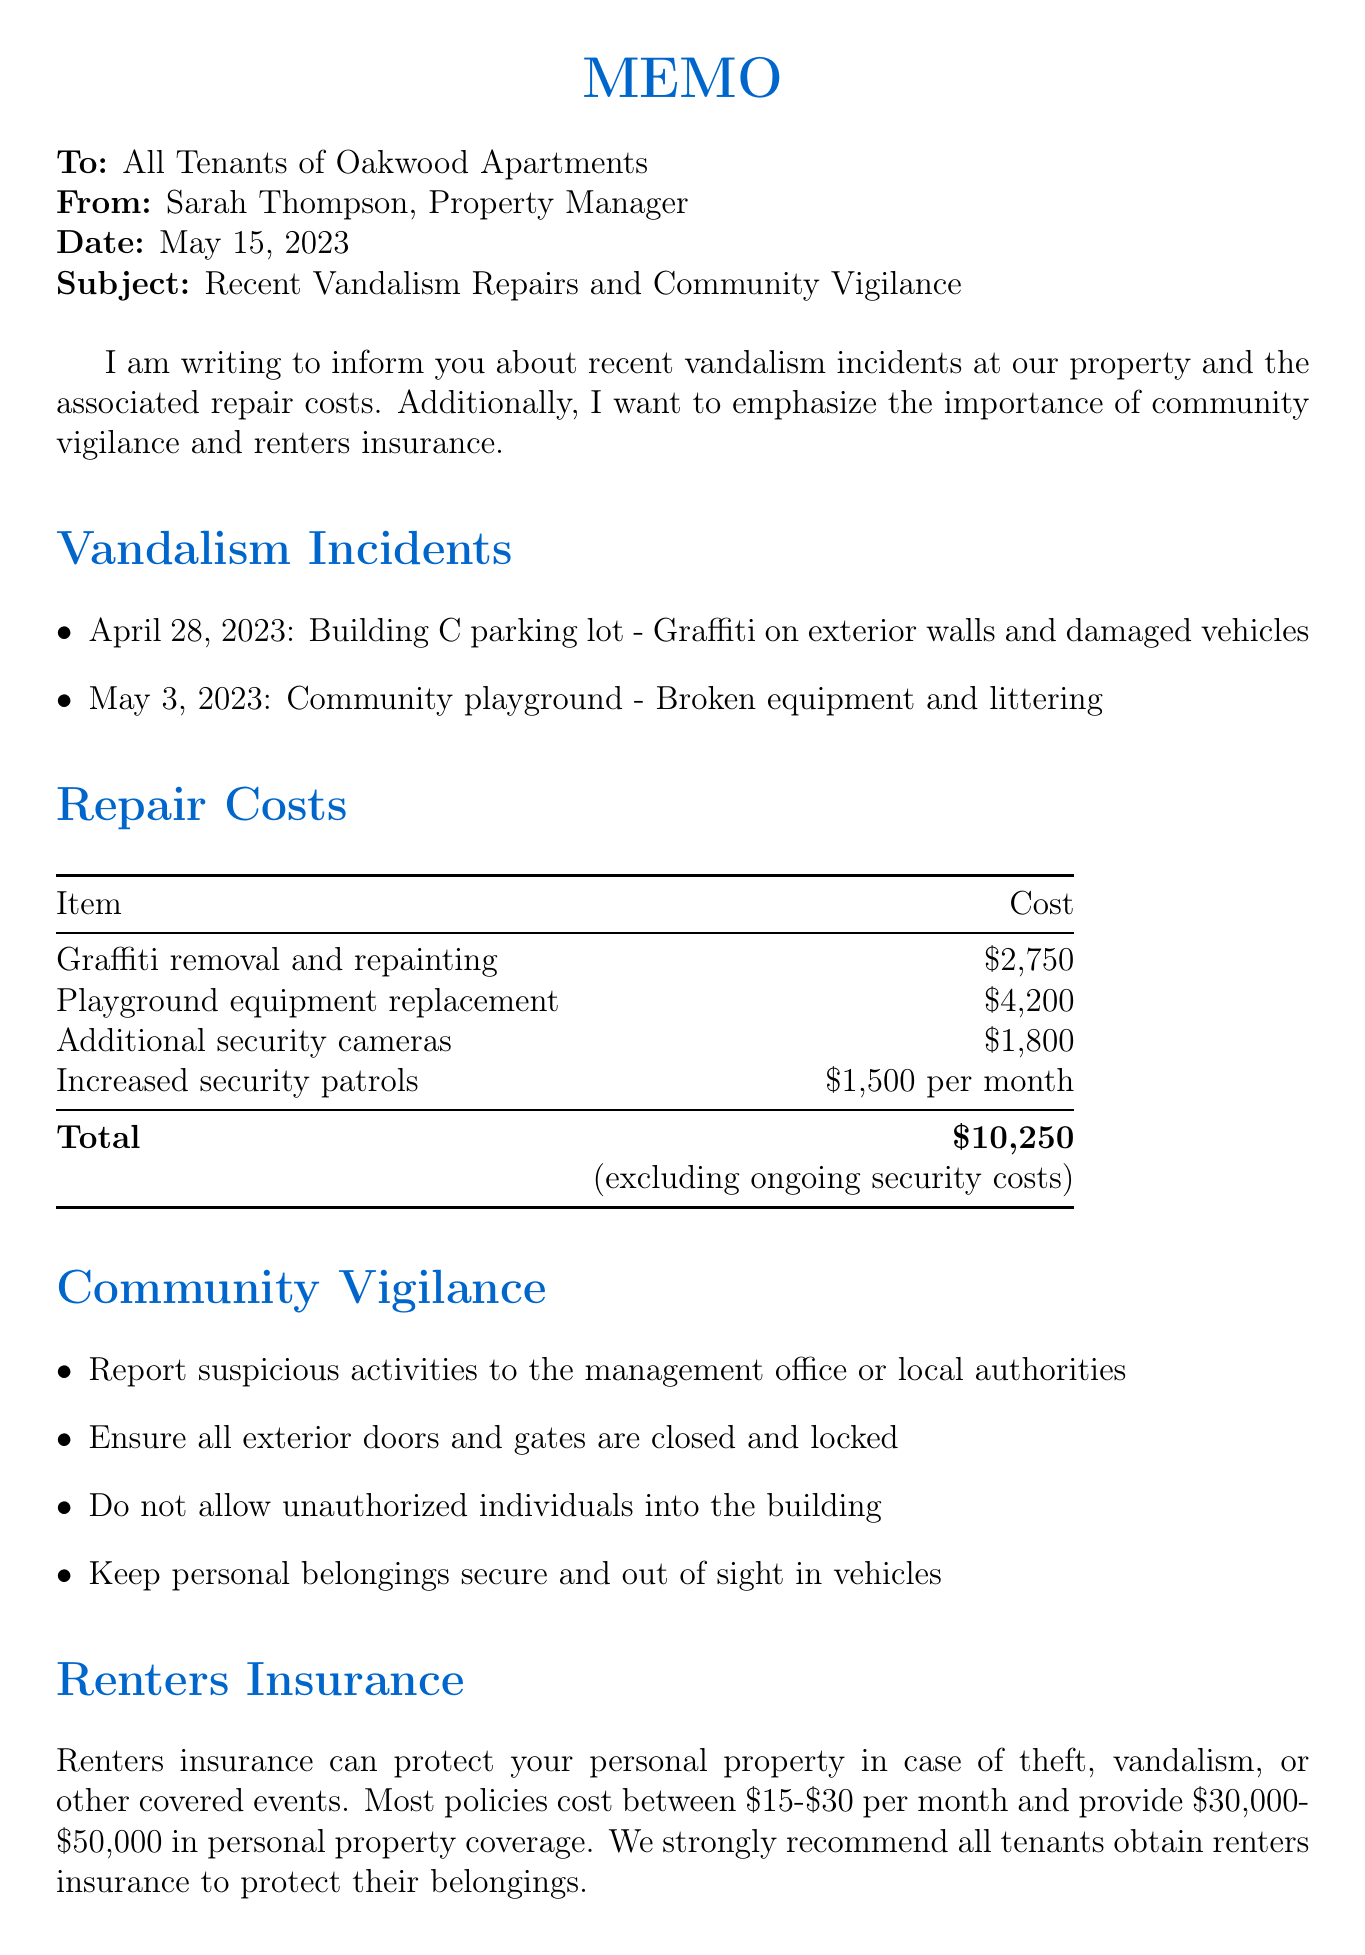what date was the memo issued? The memo was issued on May 15, 2023, as indicated in the document.
Answer: May 15, 2023 how much did the graffiti removal cost? The cost for graffiti removal and repainting is listed as $2,750 in the repair costs section.
Answer: $2,750 what was damaged in the Building C parking lot? The document mentions graffiti on exterior walls and damaged vehicles in the Building C parking lot.
Answer: Graffiti on exterior walls and damaged vehicles how much is the estimated total repair cost? The total repair cost is clearly stated as $10,250 in the repair costs table.
Answer: $10,250 what measures are suggested for community vigilance? The memo lists several measures, including reporting suspicious activities and ensuring doors are locked, highlighting the importance of community vigilance.
Answer: Report suspicious activities to the management office or local authorities what coverage do most renters insurance policies provide? The document states that most policies provide $30,000-$50,000 in personal property coverage.
Answer: $30,000-$50,000 who is the contact person for questions? The memo specifies that Sarah Thompson is the contact person for any questions or concerns.
Answer: Sarah Thompson how much do monthly renters insurance policies typically cost? The average cost of renters insurance is reported as between $15 to $30 per month.
Answer: $15-$30 